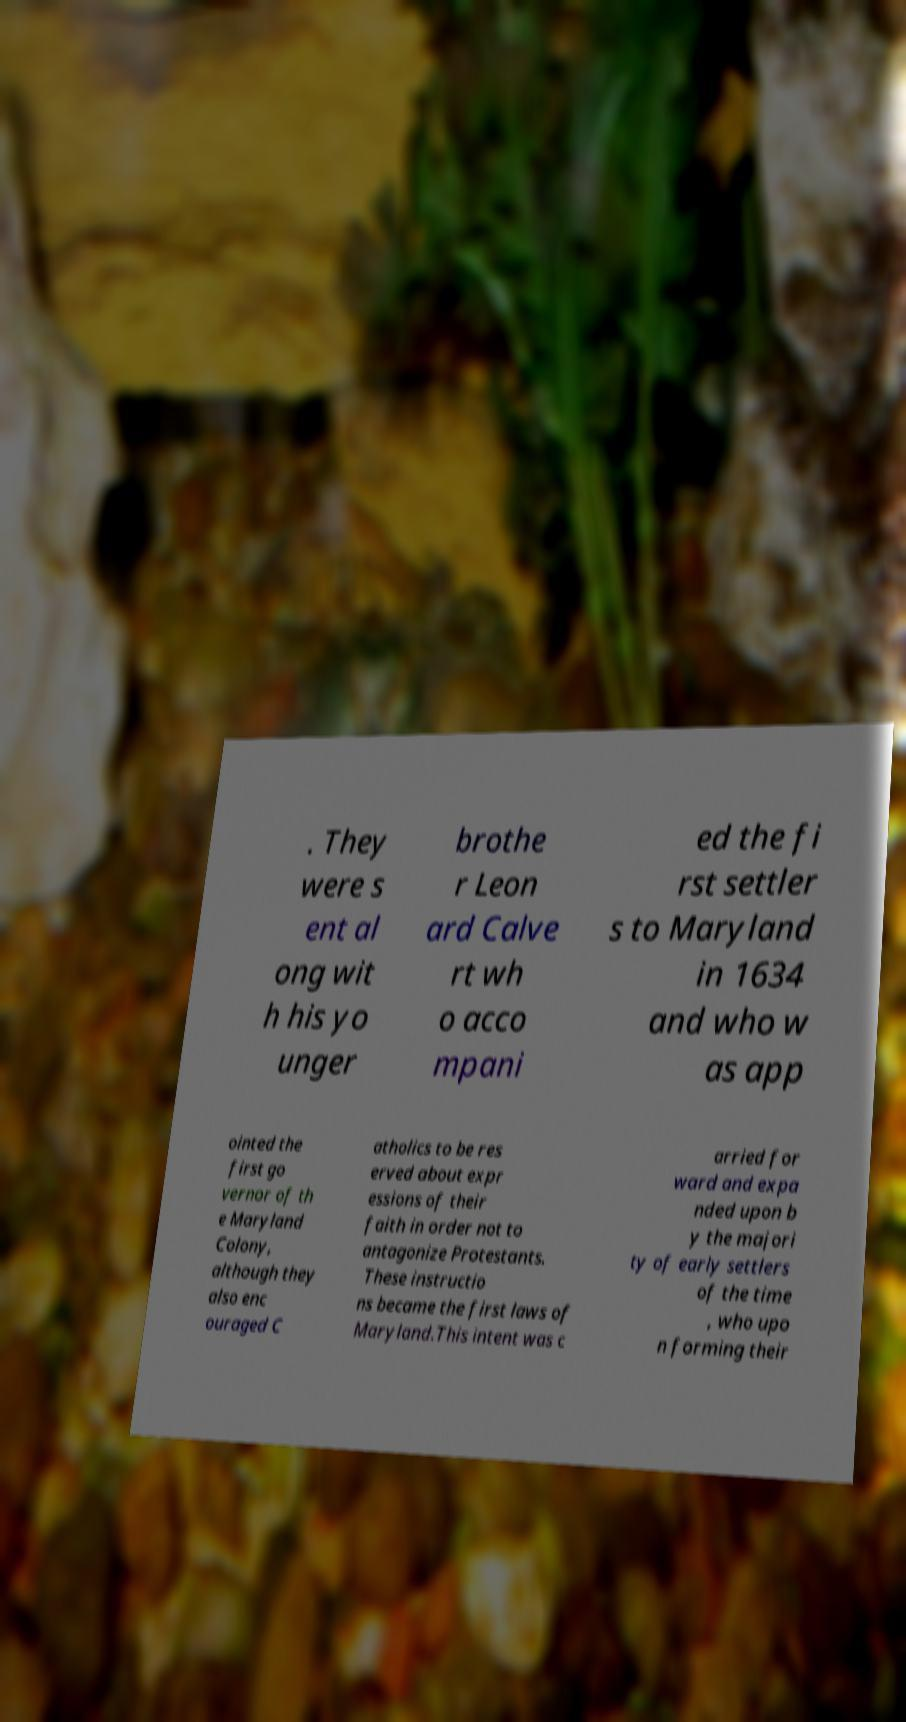Can you read and provide the text displayed in the image?This photo seems to have some interesting text. Can you extract and type it out for me? . They were s ent al ong wit h his yo unger brothe r Leon ard Calve rt wh o acco mpani ed the fi rst settler s to Maryland in 1634 and who w as app ointed the first go vernor of th e Maryland Colony, although they also enc ouraged C atholics to be res erved about expr essions of their faith in order not to antagonize Protestants. These instructio ns became the first laws of Maryland.This intent was c arried for ward and expa nded upon b y the majori ty of early settlers of the time , who upo n forming their 